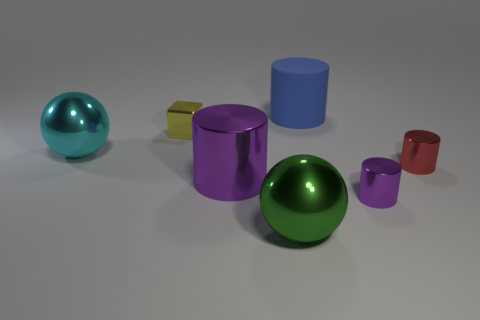Are there any cyan shiny spheres of the same size as the matte cylinder?
Provide a succinct answer. Yes. There is a small cylinder in front of the big purple thing; does it have the same color as the thing that is to the left of the yellow block?
Make the answer very short. No. Is there a metal thing that has the same color as the big shiny cylinder?
Make the answer very short. Yes. What number of other objects are the same shape as the large cyan object?
Ensure brevity in your answer.  1. There is a big object behind the big cyan metal ball; what shape is it?
Offer a terse response. Cylinder. Does the small yellow thing have the same shape as the large thing behind the cyan shiny thing?
Your answer should be very brief. No. How big is the metal object that is to the left of the big green shiny ball and in front of the tiny red shiny cylinder?
Ensure brevity in your answer.  Large. What color is the large thing that is both behind the small red cylinder and to the left of the green metallic thing?
Your response must be concise. Cyan. Are there any other things that have the same material as the yellow thing?
Your answer should be compact. Yes. Is the number of spheres that are in front of the big cyan metallic thing less than the number of large green balls to the left of the big purple object?
Give a very brief answer. No. 